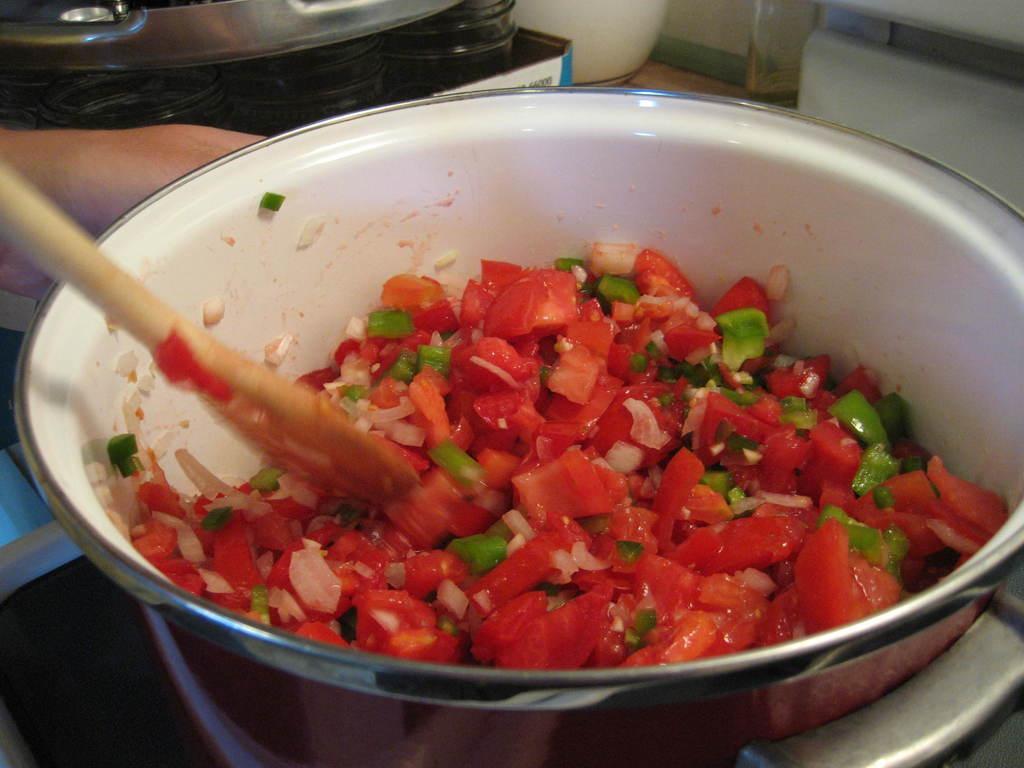In one or two sentences, can you explain what this image depicts? In this image, we can see some food in the cooking pot. Here there is a spatula. At the bottom, we can see a black object. Top of the image, we can see glass jars and few things. Here we can see a human hand. 